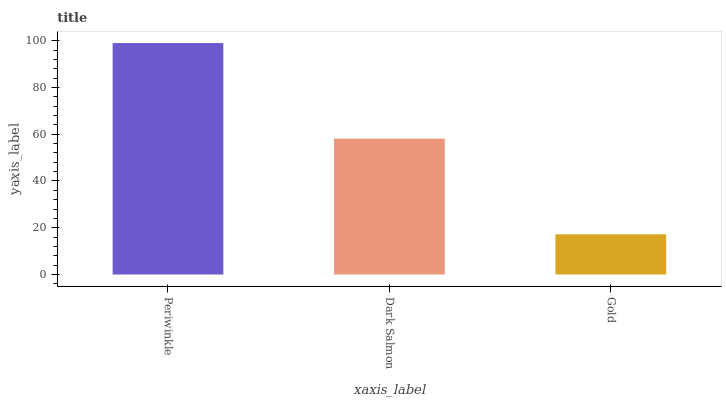Is Gold the minimum?
Answer yes or no. Yes. Is Periwinkle the maximum?
Answer yes or no. Yes. Is Dark Salmon the minimum?
Answer yes or no. No. Is Dark Salmon the maximum?
Answer yes or no. No. Is Periwinkle greater than Dark Salmon?
Answer yes or no. Yes. Is Dark Salmon less than Periwinkle?
Answer yes or no. Yes. Is Dark Salmon greater than Periwinkle?
Answer yes or no. No. Is Periwinkle less than Dark Salmon?
Answer yes or no. No. Is Dark Salmon the high median?
Answer yes or no. Yes. Is Dark Salmon the low median?
Answer yes or no. Yes. Is Periwinkle the high median?
Answer yes or no. No. Is Periwinkle the low median?
Answer yes or no. No. 